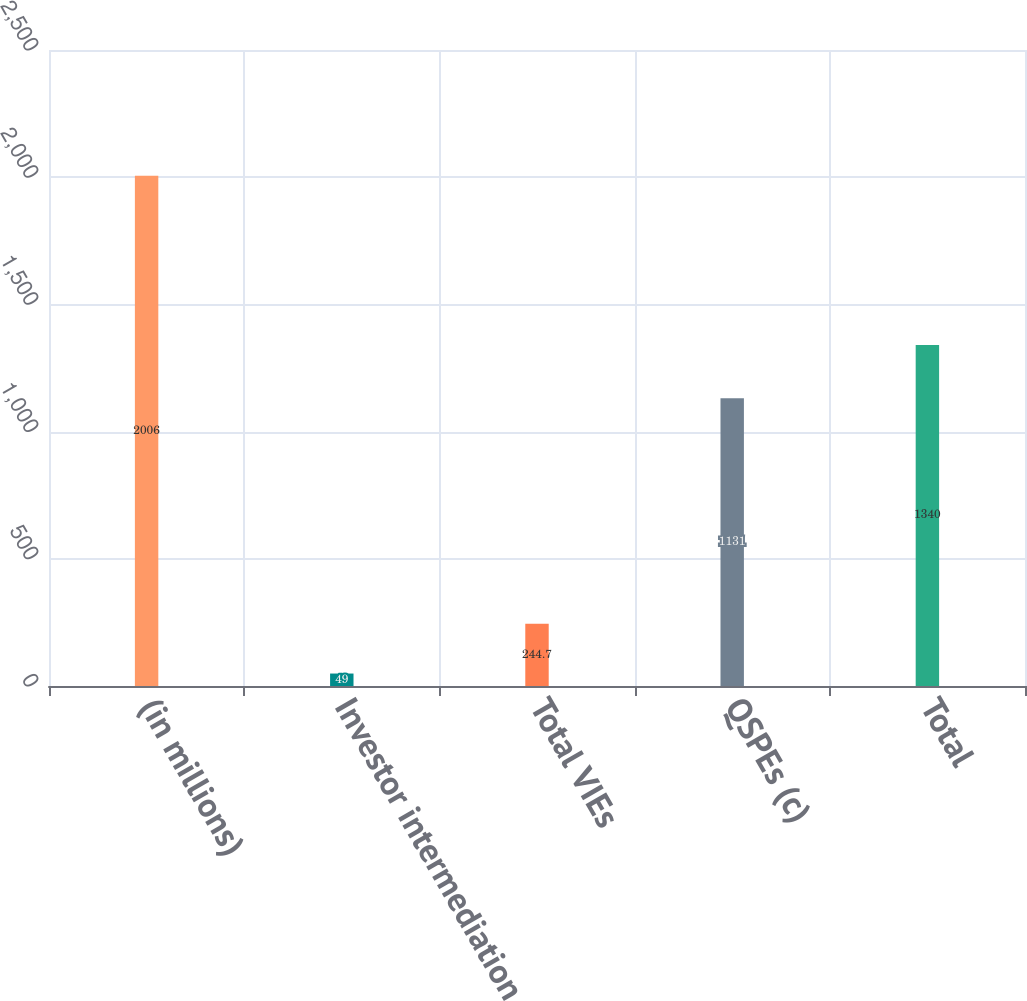<chart> <loc_0><loc_0><loc_500><loc_500><bar_chart><fcel>(in millions)<fcel>Investor intermediation<fcel>Total VIEs<fcel>QSPEs (c)<fcel>Total<nl><fcel>2006<fcel>49<fcel>244.7<fcel>1131<fcel>1340<nl></chart> 